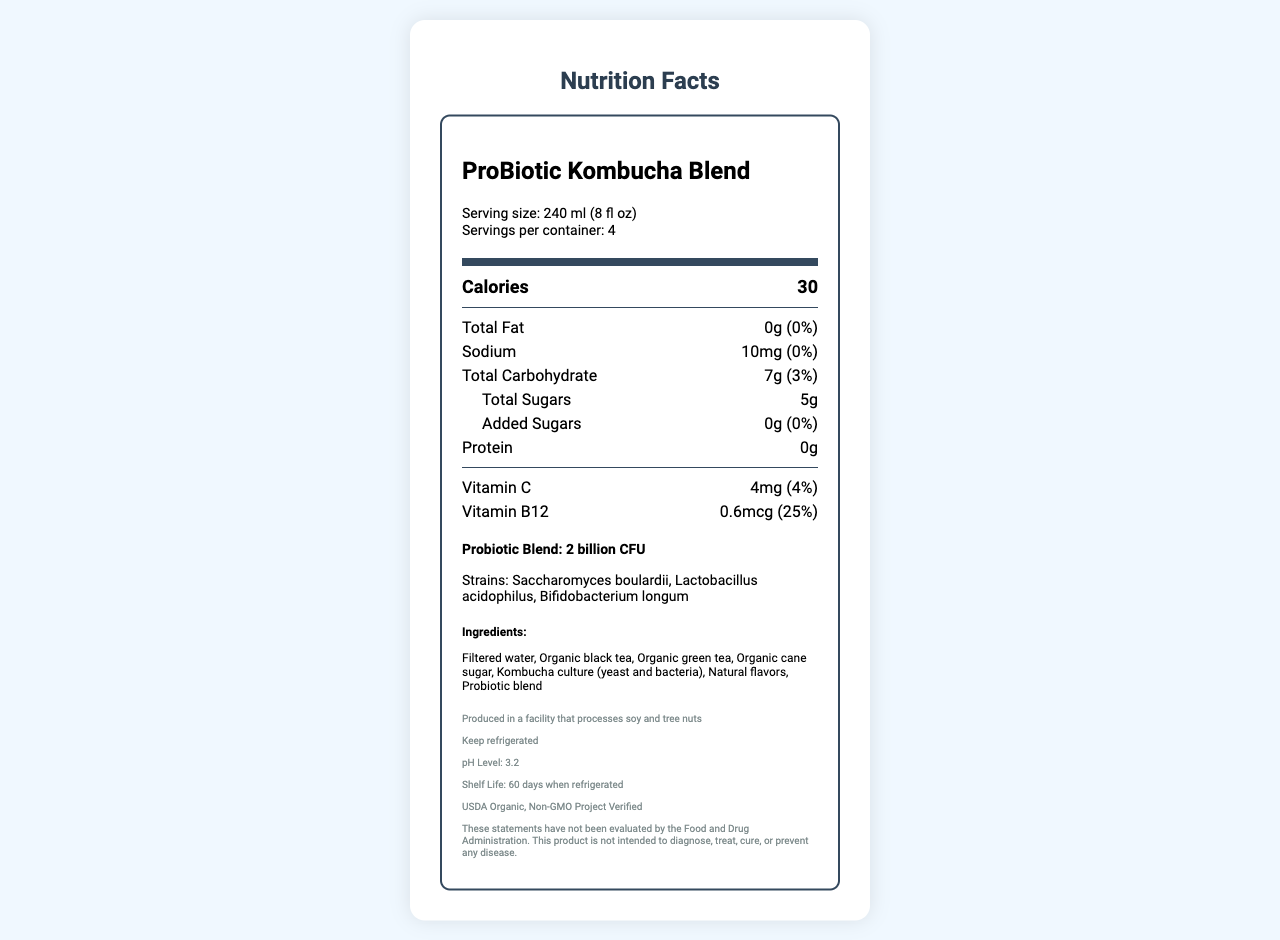what is the serving size? The serving size is explicitly mentioned at the beginning of the document under the "Serving size" label.
Answer: 240 ml (8 fl oz) how many servings are in the container? The document states that there are "Servings per container: 4" under the serving size information.
Answer: 4 how many calories are per serving? The information is listed directly under the "Calories" section in the nutrient details.
Answer: 30 how much sodium is there per serving? The sodium amount is listed as "10mg" with a daily value of "0%" under the sodium section in the nutrient details.
Answer: 10mg who is the manufacturer of this product? The manufacturer's name can be found towards the end of the document under the footnote section.
Answer: BioBrewTech Laboratories, Inc. what are the ingredients in the product? The ingredients are listed in the section labeled "Ingredients."
Answer: Filtered water, Organic black tea, Organic green tea, Organic cane sugar, Kombucha culture (yeast and bacteria), Natural flavors, Probiotic blend what is the pH level of the drink? The pH level is mentioned towards the end of the document under the footnote section.
Answer: 3.2 how long is the shelf life when refrigerated? The shelf life information is provided towards the end of the document under the footnote section.
Answer: 60 days how much vitamin B12 does the product contain? The document specifies that the product contains "0.6mcg" of vitamin B12, with a daily value of "25%."
Answer: 0.6mcg what is the total plate count in the microbiological analysis? The microbiological analysis section states that the total plate count is "<1000 CFU/ml."
Answer: <1000 CFU/ml which of the following is a strain included in the probiotic blend? A. Saccharomyces boulardii B. Escherichia coli C. Streptococcus thermophilus D. Bacillus subtilis The probiotic strains listed in the document are "Saccharomyces boulardii, Lactobacillus acidophilus, Bifidobacterium longum."
Answer: A. Saccharomyces boulardii which certification does this product have? A. USDA Organic B. Fair Trade C. Certified Vegan D. Gluten-Free The certifications listed are "USDA Organic, Non-GMO Project Verified."
Answer: A. USDA Organic does the product contain added sugars? The document explicitly states that there are "0g" of added sugars, confirmed by the daily value of "0%."
Answer: No is the product safe for individuals with soy allergies? The document states that it is "Produced in a facility that processes soy and tree nuts," which might not be safe for individuals with soy allergies.
Answer: No given the information, what is the main idea of this document? The document summarizes the nutritional content and relevant health information for the ProBiotic Kombucha Blend to inform consumers about what they are consuming and any related safety aspects.
Answer: This document provides the nutrition facts for the ProBiotic Kombucha Blend, detailing the serving size, calorie content, macronutrient breakdown, vitamins, probiotic blend, ingredients, allergen information, storage instructions, microbiological analysis, pH level, shelf life, manufacturer, and certifications. what is the concentration of Escherichia coli in the product? The document states "Escherichia coli: Negative/100ml," which doesn't provide a concentration but indicates its absence.
Answer: Not enough information 